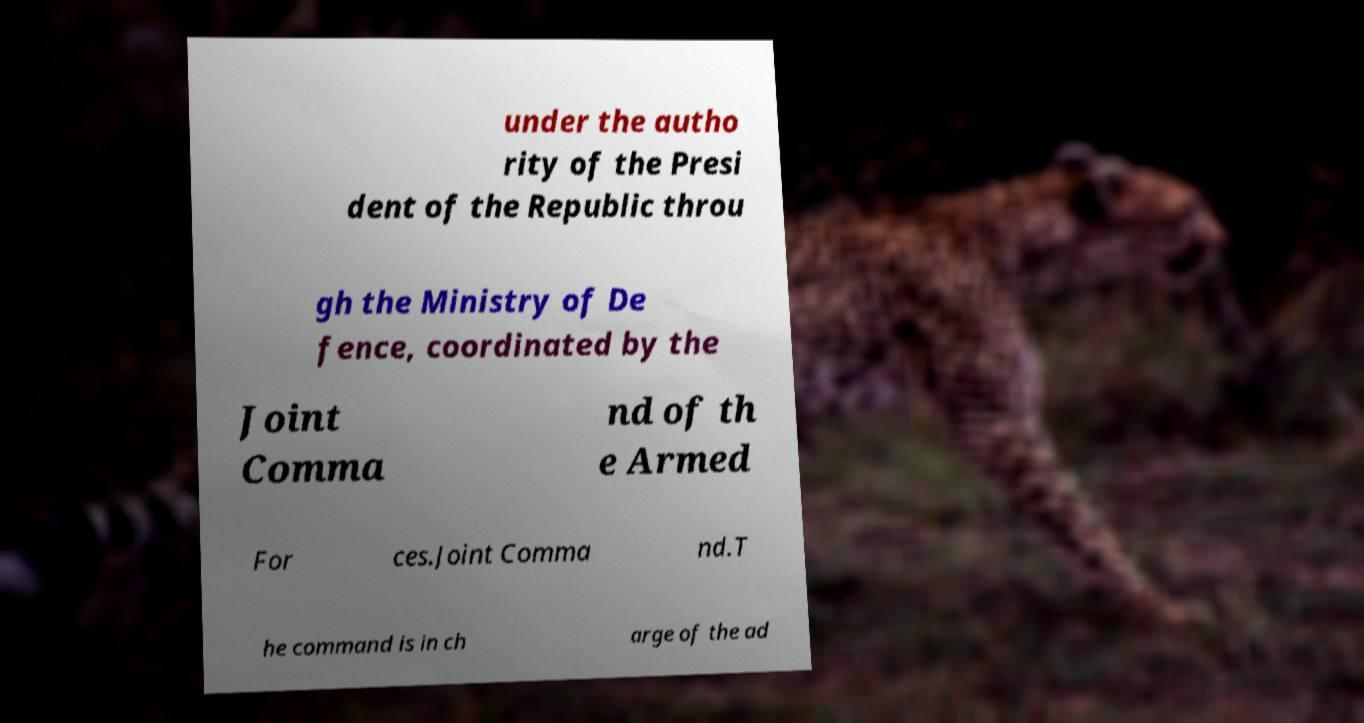Can you accurately transcribe the text from the provided image for me? under the autho rity of the Presi dent of the Republic throu gh the Ministry of De fence, coordinated by the Joint Comma nd of th e Armed For ces.Joint Comma nd.T he command is in ch arge of the ad 